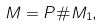Convert formula to latex. <formula><loc_0><loc_0><loc_500><loc_500>M = P \# M _ { 1 } ,</formula> 